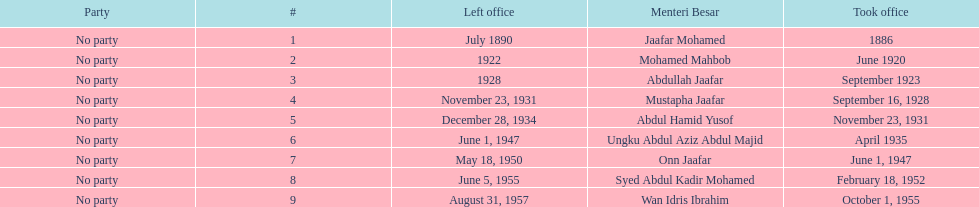Who was in office previous to abdullah jaafar? Mohamed Mahbob. 